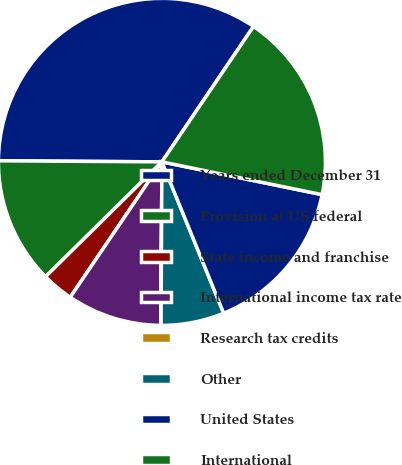Convert chart. <chart><loc_0><loc_0><loc_500><loc_500><pie_chart><fcel>Years ended December 31<fcel>Provision at US federal<fcel>State income and franchise<fcel>International income tax rate<fcel>Research tax credits<fcel>Other<fcel>United States<fcel>International<nl><fcel>34.36%<fcel>12.5%<fcel>3.13%<fcel>9.38%<fcel>0.01%<fcel>6.25%<fcel>15.62%<fcel>18.75%<nl></chart> 